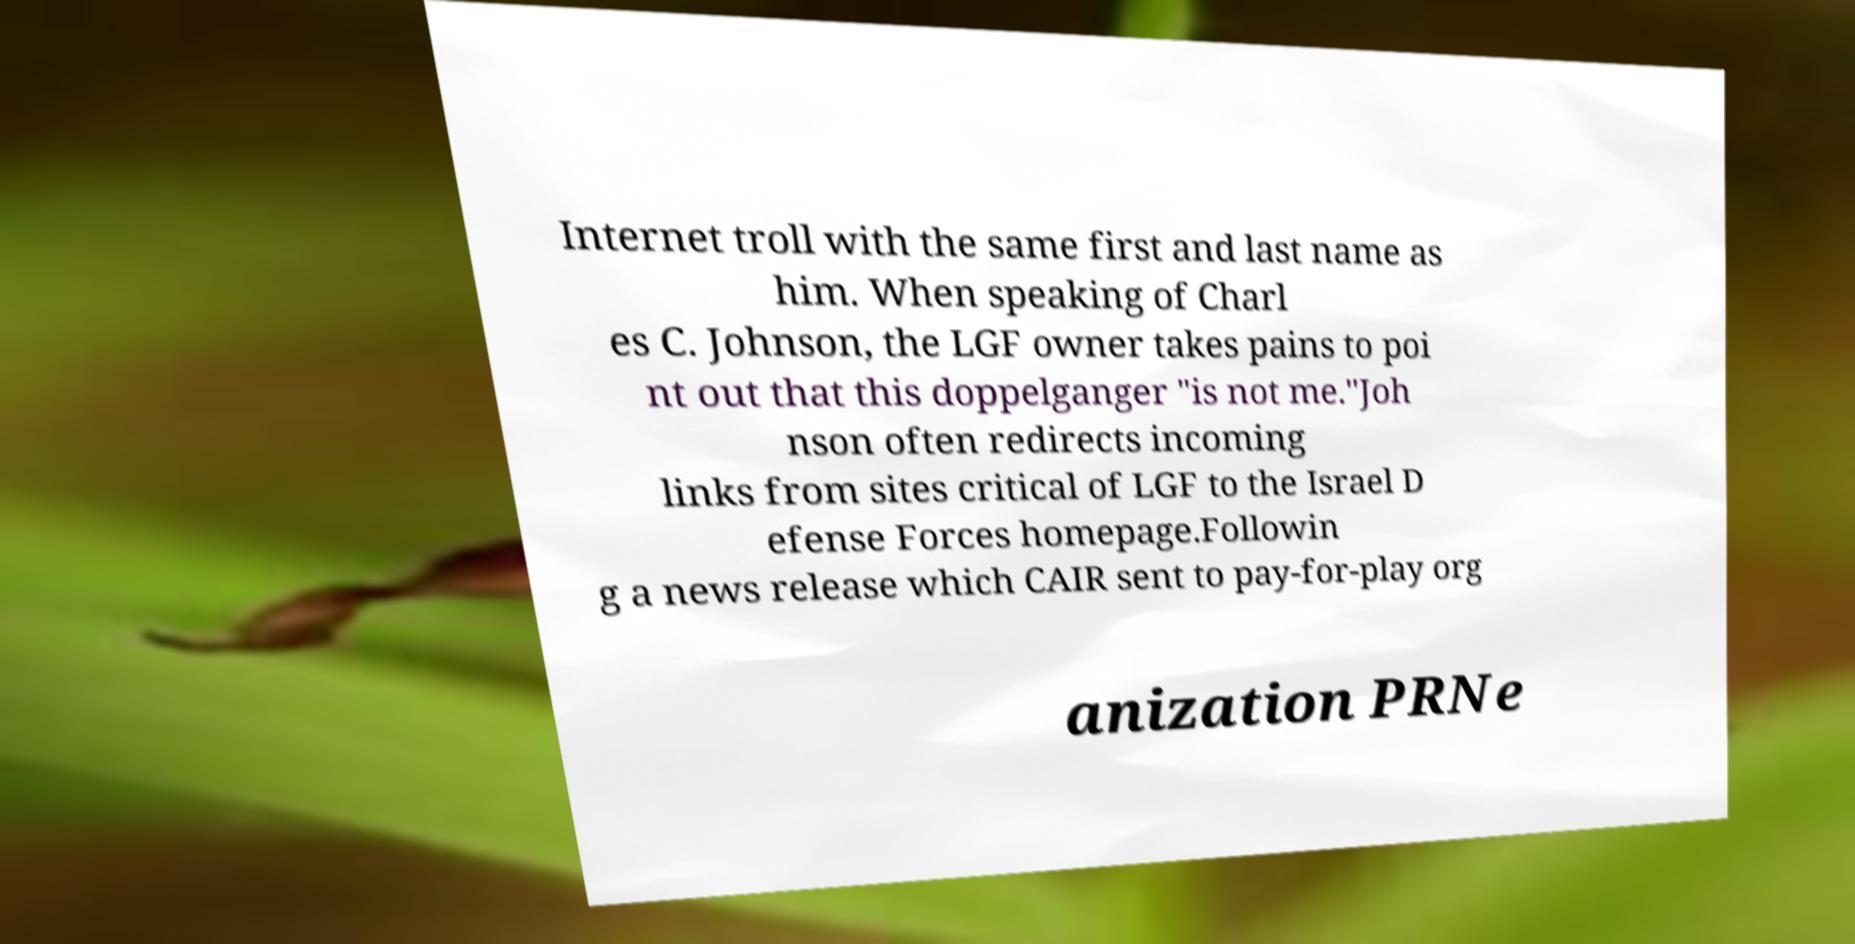Could you assist in decoding the text presented in this image and type it out clearly? Internet troll with the same first and last name as him. When speaking of Charl es C. Johnson, the LGF owner takes pains to poi nt out that this doppelganger "is not me."Joh nson often redirects incoming links from sites critical of LGF to the Israel D efense Forces homepage.Followin g a news release which CAIR sent to pay-for-play org anization PRNe 